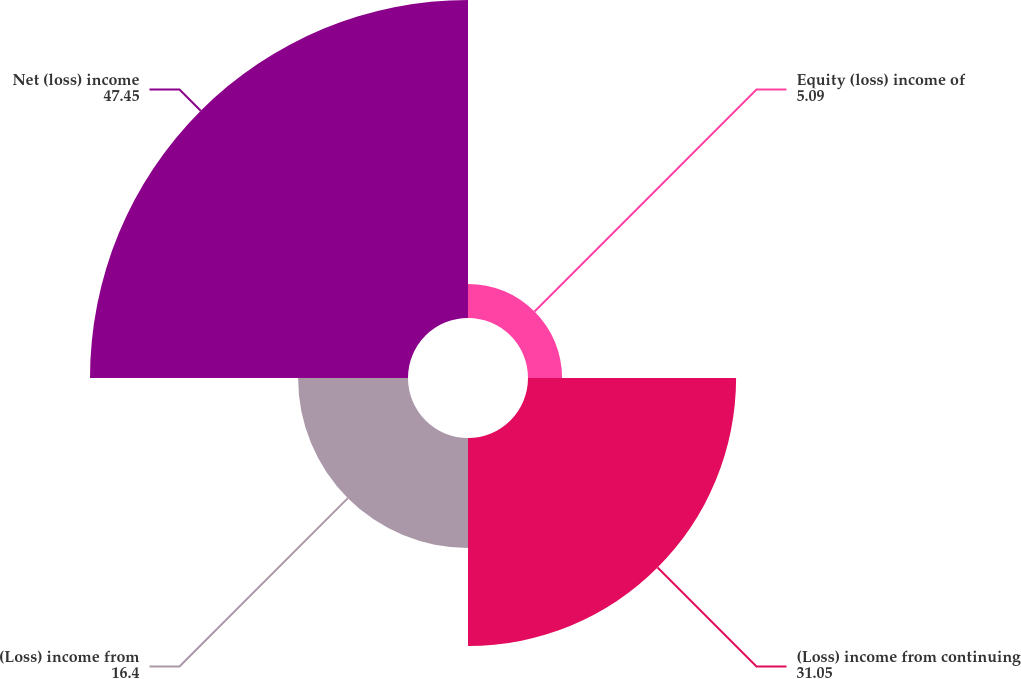Convert chart. <chart><loc_0><loc_0><loc_500><loc_500><pie_chart><fcel>Equity (loss) income of<fcel>(Loss) income from continuing<fcel>(Loss) income from<fcel>Net (loss) income<nl><fcel>5.09%<fcel>31.05%<fcel>16.4%<fcel>47.45%<nl></chart> 